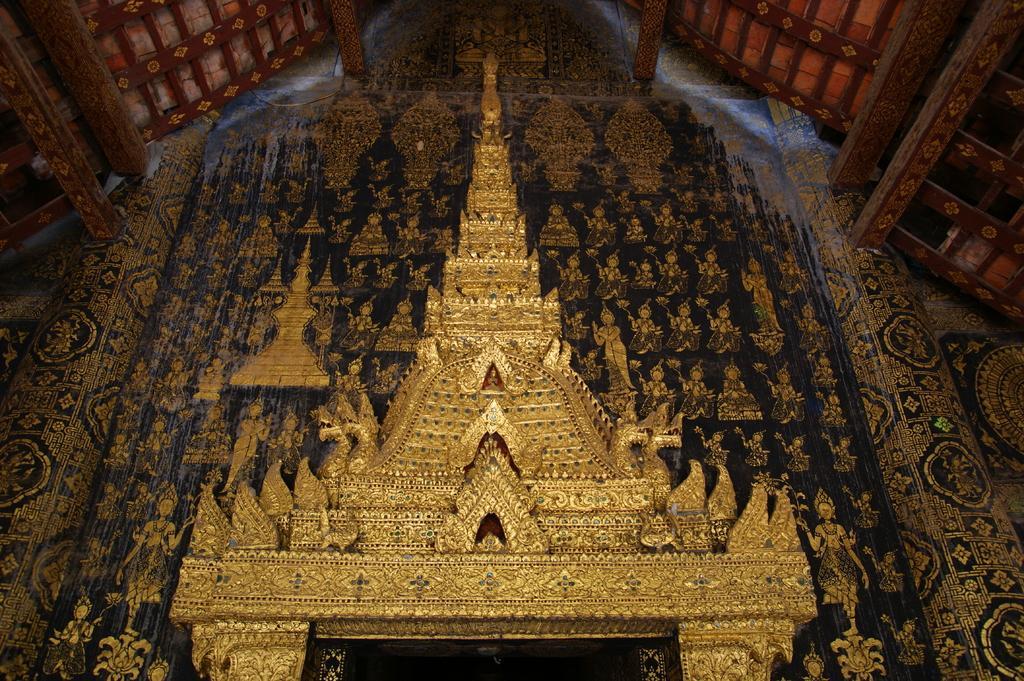In one or two sentences, can you explain what this image depicts? In the picture we can see a Chinese temple which is constructed with a gold and under the shed and to the wall we can see some designs. 